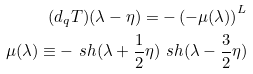Convert formula to latex. <formula><loc_0><loc_0><loc_500><loc_500>( d _ { q } T ) ( \lambda - \eta ) = - \left ( - \mu ( \lambda ) \right ) ^ { L } \\ \mu ( \lambda ) \equiv - \ s h ( \lambda + \frac { 1 } { 2 } \eta ) \ s h ( \lambda - \frac { 3 } { 2 } \eta )</formula> 